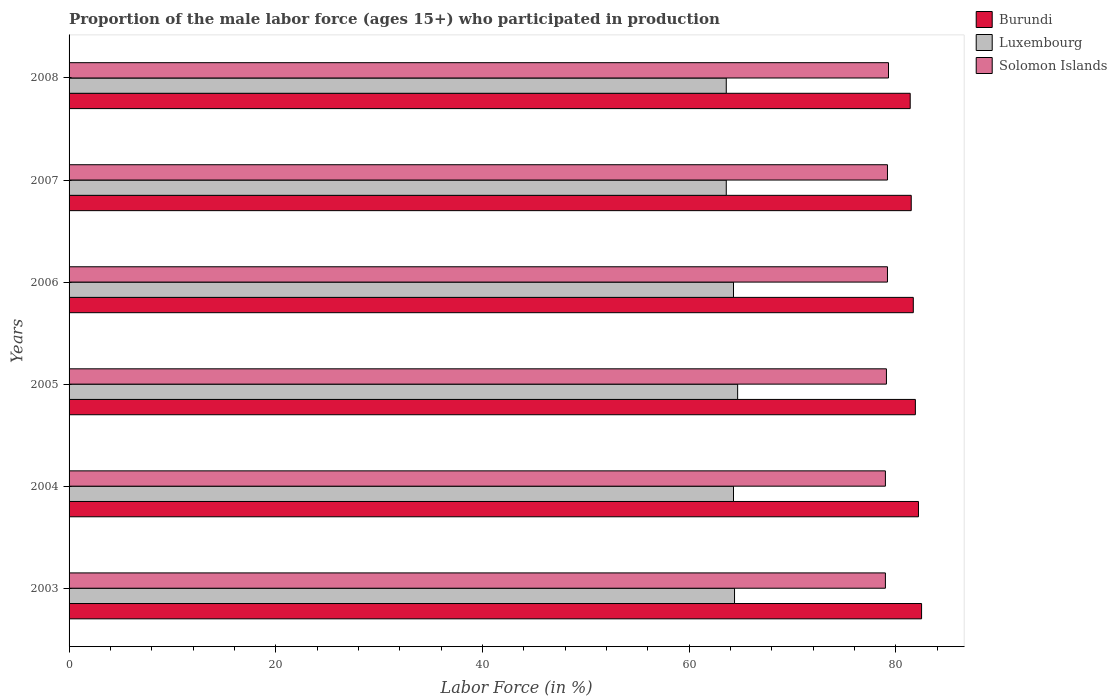Are the number of bars per tick equal to the number of legend labels?
Make the answer very short. Yes. Are the number of bars on each tick of the Y-axis equal?
Offer a very short reply. Yes. How many bars are there on the 3rd tick from the top?
Keep it short and to the point. 3. What is the label of the 4th group of bars from the top?
Your answer should be very brief. 2005. What is the proportion of the male labor force who participated in production in Solomon Islands in 2008?
Your answer should be compact. 79.3. Across all years, what is the maximum proportion of the male labor force who participated in production in Burundi?
Offer a very short reply. 82.5. Across all years, what is the minimum proportion of the male labor force who participated in production in Burundi?
Your answer should be very brief. 81.4. In which year was the proportion of the male labor force who participated in production in Burundi minimum?
Provide a short and direct response. 2008. What is the total proportion of the male labor force who participated in production in Solomon Islands in the graph?
Keep it short and to the point. 474.8. What is the difference between the proportion of the male labor force who participated in production in Solomon Islands in 2004 and that in 2007?
Give a very brief answer. -0.2. What is the difference between the proportion of the male labor force who participated in production in Luxembourg in 2006 and the proportion of the male labor force who participated in production in Burundi in 2005?
Make the answer very short. -17.6. What is the average proportion of the male labor force who participated in production in Burundi per year?
Offer a terse response. 81.87. In the year 2003, what is the difference between the proportion of the male labor force who participated in production in Luxembourg and proportion of the male labor force who participated in production in Solomon Islands?
Provide a succinct answer. -14.6. In how many years, is the proportion of the male labor force who participated in production in Luxembourg greater than 4 %?
Make the answer very short. 6. What is the ratio of the proportion of the male labor force who participated in production in Burundi in 2005 to that in 2006?
Provide a short and direct response. 1. Is the proportion of the male labor force who participated in production in Solomon Islands in 2004 less than that in 2006?
Give a very brief answer. Yes. Is the difference between the proportion of the male labor force who participated in production in Luxembourg in 2005 and 2008 greater than the difference between the proportion of the male labor force who participated in production in Solomon Islands in 2005 and 2008?
Keep it short and to the point. Yes. What is the difference between the highest and the second highest proportion of the male labor force who participated in production in Solomon Islands?
Your response must be concise. 0.1. What is the difference between the highest and the lowest proportion of the male labor force who participated in production in Luxembourg?
Your answer should be very brief. 1.1. Is the sum of the proportion of the male labor force who participated in production in Luxembourg in 2004 and 2006 greater than the maximum proportion of the male labor force who participated in production in Solomon Islands across all years?
Offer a very short reply. Yes. What does the 2nd bar from the top in 2004 represents?
Make the answer very short. Luxembourg. What does the 3rd bar from the bottom in 2004 represents?
Provide a succinct answer. Solomon Islands. Are all the bars in the graph horizontal?
Provide a succinct answer. Yes. Are the values on the major ticks of X-axis written in scientific E-notation?
Keep it short and to the point. No. Where does the legend appear in the graph?
Provide a succinct answer. Top right. How many legend labels are there?
Your answer should be compact. 3. What is the title of the graph?
Ensure brevity in your answer.  Proportion of the male labor force (ages 15+) who participated in production. What is the Labor Force (in %) in Burundi in 2003?
Provide a short and direct response. 82.5. What is the Labor Force (in %) in Luxembourg in 2003?
Ensure brevity in your answer.  64.4. What is the Labor Force (in %) in Solomon Islands in 2003?
Offer a very short reply. 79. What is the Labor Force (in %) of Burundi in 2004?
Offer a very short reply. 82.2. What is the Labor Force (in %) in Luxembourg in 2004?
Ensure brevity in your answer.  64.3. What is the Labor Force (in %) in Solomon Islands in 2004?
Provide a succinct answer. 79. What is the Labor Force (in %) in Burundi in 2005?
Your answer should be very brief. 81.9. What is the Labor Force (in %) of Luxembourg in 2005?
Give a very brief answer. 64.7. What is the Labor Force (in %) in Solomon Islands in 2005?
Your answer should be compact. 79.1. What is the Labor Force (in %) of Burundi in 2006?
Provide a short and direct response. 81.7. What is the Labor Force (in %) of Luxembourg in 2006?
Give a very brief answer. 64.3. What is the Labor Force (in %) in Solomon Islands in 2006?
Give a very brief answer. 79.2. What is the Labor Force (in %) of Burundi in 2007?
Ensure brevity in your answer.  81.5. What is the Labor Force (in %) of Luxembourg in 2007?
Provide a succinct answer. 63.6. What is the Labor Force (in %) of Solomon Islands in 2007?
Offer a terse response. 79.2. What is the Labor Force (in %) of Burundi in 2008?
Offer a very short reply. 81.4. What is the Labor Force (in %) in Luxembourg in 2008?
Offer a terse response. 63.6. What is the Labor Force (in %) of Solomon Islands in 2008?
Ensure brevity in your answer.  79.3. Across all years, what is the maximum Labor Force (in %) in Burundi?
Give a very brief answer. 82.5. Across all years, what is the maximum Labor Force (in %) of Luxembourg?
Provide a succinct answer. 64.7. Across all years, what is the maximum Labor Force (in %) of Solomon Islands?
Offer a very short reply. 79.3. Across all years, what is the minimum Labor Force (in %) of Burundi?
Your answer should be very brief. 81.4. Across all years, what is the minimum Labor Force (in %) of Luxembourg?
Ensure brevity in your answer.  63.6. Across all years, what is the minimum Labor Force (in %) in Solomon Islands?
Keep it short and to the point. 79. What is the total Labor Force (in %) in Burundi in the graph?
Offer a terse response. 491.2. What is the total Labor Force (in %) in Luxembourg in the graph?
Give a very brief answer. 384.9. What is the total Labor Force (in %) of Solomon Islands in the graph?
Provide a succinct answer. 474.8. What is the difference between the Labor Force (in %) in Burundi in 2003 and that in 2004?
Ensure brevity in your answer.  0.3. What is the difference between the Labor Force (in %) in Luxembourg in 2003 and that in 2004?
Offer a terse response. 0.1. What is the difference between the Labor Force (in %) of Burundi in 2003 and that in 2005?
Offer a very short reply. 0.6. What is the difference between the Labor Force (in %) in Luxembourg in 2003 and that in 2005?
Your answer should be very brief. -0.3. What is the difference between the Labor Force (in %) in Burundi in 2003 and that in 2006?
Your answer should be compact. 0.8. What is the difference between the Labor Force (in %) in Solomon Islands in 2003 and that in 2006?
Your answer should be compact. -0.2. What is the difference between the Labor Force (in %) in Solomon Islands in 2003 and that in 2008?
Give a very brief answer. -0.3. What is the difference between the Labor Force (in %) of Burundi in 2004 and that in 2005?
Offer a terse response. 0.3. What is the difference between the Labor Force (in %) in Solomon Islands in 2004 and that in 2005?
Keep it short and to the point. -0.1. What is the difference between the Labor Force (in %) in Luxembourg in 2004 and that in 2006?
Your response must be concise. 0. What is the difference between the Labor Force (in %) in Solomon Islands in 2004 and that in 2006?
Keep it short and to the point. -0.2. What is the difference between the Labor Force (in %) of Solomon Islands in 2004 and that in 2007?
Provide a short and direct response. -0.2. What is the difference between the Labor Force (in %) in Luxembourg in 2004 and that in 2008?
Your answer should be compact. 0.7. What is the difference between the Labor Force (in %) in Burundi in 2005 and that in 2006?
Your answer should be compact. 0.2. What is the difference between the Labor Force (in %) in Burundi in 2005 and that in 2007?
Give a very brief answer. 0.4. What is the difference between the Labor Force (in %) of Luxembourg in 2005 and that in 2007?
Your answer should be compact. 1.1. What is the difference between the Labor Force (in %) in Solomon Islands in 2005 and that in 2007?
Offer a very short reply. -0.1. What is the difference between the Labor Force (in %) of Burundi in 2005 and that in 2008?
Provide a succinct answer. 0.5. What is the difference between the Labor Force (in %) in Luxembourg in 2005 and that in 2008?
Provide a short and direct response. 1.1. What is the difference between the Labor Force (in %) of Solomon Islands in 2005 and that in 2008?
Offer a terse response. -0.2. What is the difference between the Labor Force (in %) of Solomon Islands in 2006 and that in 2007?
Give a very brief answer. 0. What is the difference between the Labor Force (in %) of Burundi in 2006 and that in 2008?
Provide a succinct answer. 0.3. What is the difference between the Labor Force (in %) of Solomon Islands in 2006 and that in 2008?
Provide a short and direct response. -0.1. What is the difference between the Labor Force (in %) in Luxembourg in 2007 and that in 2008?
Make the answer very short. 0. What is the difference between the Labor Force (in %) of Solomon Islands in 2007 and that in 2008?
Offer a terse response. -0.1. What is the difference between the Labor Force (in %) of Burundi in 2003 and the Labor Force (in %) of Solomon Islands in 2004?
Ensure brevity in your answer.  3.5. What is the difference between the Labor Force (in %) in Luxembourg in 2003 and the Labor Force (in %) in Solomon Islands in 2004?
Ensure brevity in your answer.  -14.6. What is the difference between the Labor Force (in %) of Burundi in 2003 and the Labor Force (in %) of Luxembourg in 2005?
Offer a very short reply. 17.8. What is the difference between the Labor Force (in %) of Luxembourg in 2003 and the Labor Force (in %) of Solomon Islands in 2005?
Your response must be concise. -14.7. What is the difference between the Labor Force (in %) of Burundi in 2003 and the Labor Force (in %) of Solomon Islands in 2006?
Give a very brief answer. 3.3. What is the difference between the Labor Force (in %) of Luxembourg in 2003 and the Labor Force (in %) of Solomon Islands in 2006?
Ensure brevity in your answer.  -14.8. What is the difference between the Labor Force (in %) in Luxembourg in 2003 and the Labor Force (in %) in Solomon Islands in 2007?
Provide a short and direct response. -14.8. What is the difference between the Labor Force (in %) in Burundi in 2003 and the Labor Force (in %) in Luxembourg in 2008?
Keep it short and to the point. 18.9. What is the difference between the Labor Force (in %) of Luxembourg in 2003 and the Labor Force (in %) of Solomon Islands in 2008?
Provide a succinct answer. -14.9. What is the difference between the Labor Force (in %) in Luxembourg in 2004 and the Labor Force (in %) in Solomon Islands in 2005?
Your response must be concise. -14.8. What is the difference between the Labor Force (in %) of Burundi in 2004 and the Labor Force (in %) of Luxembourg in 2006?
Make the answer very short. 17.9. What is the difference between the Labor Force (in %) of Luxembourg in 2004 and the Labor Force (in %) of Solomon Islands in 2006?
Your answer should be very brief. -14.9. What is the difference between the Labor Force (in %) of Burundi in 2004 and the Labor Force (in %) of Solomon Islands in 2007?
Ensure brevity in your answer.  3. What is the difference between the Labor Force (in %) in Luxembourg in 2004 and the Labor Force (in %) in Solomon Islands in 2007?
Ensure brevity in your answer.  -14.9. What is the difference between the Labor Force (in %) of Burundi in 2004 and the Labor Force (in %) of Luxembourg in 2008?
Your answer should be very brief. 18.6. What is the difference between the Labor Force (in %) in Burundi in 2005 and the Labor Force (in %) in Luxembourg in 2006?
Offer a very short reply. 17.6. What is the difference between the Labor Force (in %) in Burundi in 2005 and the Labor Force (in %) in Solomon Islands in 2006?
Your answer should be compact. 2.7. What is the difference between the Labor Force (in %) in Luxembourg in 2005 and the Labor Force (in %) in Solomon Islands in 2006?
Offer a very short reply. -14.5. What is the difference between the Labor Force (in %) in Burundi in 2005 and the Labor Force (in %) in Solomon Islands in 2007?
Keep it short and to the point. 2.7. What is the difference between the Labor Force (in %) in Burundi in 2005 and the Labor Force (in %) in Luxembourg in 2008?
Make the answer very short. 18.3. What is the difference between the Labor Force (in %) of Luxembourg in 2005 and the Labor Force (in %) of Solomon Islands in 2008?
Give a very brief answer. -14.6. What is the difference between the Labor Force (in %) of Burundi in 2006 and the Labor Force (in %) of Luxembourg in 2007?
Provide a short and direct response. 18.1. What is the difference between the Labor Force (in %) of Luxembourg in 2006 and the Labor Force (in %) of Solomon Islands in 2007?
Your response must be concise. -14.9. What is the difference between the Labor Force (in %) in Luxembourg in 2007 and the Labor Force (in %) in Solomon Islands in 2008?
Your answer should be very brief. -15.7. What is the average Labor Force (in %) in Burundi per year?
Give a very brief answer. 81.87. What is the average Labor Force (in %) in Luxembourg per year?
Your answer should be compact. 64.15. What is the average Labor Force (in %) of Solomon Islands per year?
Offer a very short reply. 79.13. In the year 2003, what is the difference between the Labor Force (in %) of Burundi and Labor Force (in %) of Solomon Islands?
Your response must be concise. 3.5. In the year 2003, what is the difference between the Labor Force (in %) in Luxembourg and Labor Force (in %) in Solomon Islands?
Your answer should be compact. -14.6. In the year 2004, what is the difference between the Labor Force (in %) in Burundi and Labor Force (in %) in Luxembourg?
Offer a terse response. 17.9. In the year 2004, what is the difference between the Labor Force (in %) of Burundi and Labor Force (in %) of Solomon Islands?
Keep it short and to the point. 3.2. In the year 2004, what is the difference between the Labor Force (in %) in Luxembourg and Labor Force (in %) in Solomon Islands?
Provide a short and direct response. -14.7. In the year 2005, what is the difference between the Labor Force (in %) of Burundi and Labor Force (in %) of Solomon Islands?
Your answer should be very brief. 2.8. In the year 2005, what is the difference between the Labor Force (in %) of Luxembourg and Labor Force (in %) of Solomon Islands?
Make the answer very short. -14.4. In the year 2006, what is the difference between the Labor Force (in %) of Burundi and Labor Force (in %) of Luxembourg?
Offer a very short reply. 17.4. In the year 2006, what is the difference between the Labor Force (in %) of Burundi and Labor Force (in %) of Solomon Islands?
Offer a very short reply. 2.5. In the year 2006, what is the difference between the Labor Force (in %) in Luxembourg and Labor Force (in %) in Solomon Islands?
Keep it short and to the point. -14.9. In the year 2007, what is the difference between the Labor Force (in %) of Burundi and Labor Force (in %) of Luxembourg?
Make the answer very short. 17.9. In the year 2007, what is the difference between the Labor Force (in %) in Burundi and Labor Force (in %) in Solomon Islands?
Provide a succinct answer. 2.3. In the year 2007, what is the difference between the Labor Force (in %) of Luxembourg and Labor Force (in %) of Solomon Islands?
Make the answer very short. -15.6. In the year 2008, what is the difference between the Labor Force (in %) in Burundi and Labor Force (in %) in Luxembourg?
Your answer should be compact. 17.8. In the year 2008, what is the difference between the Labor Force (in %) in Luxembourg and Labor Force (in %) in Solomon Islands?
Your answer should be very brief. -15.7. What is the ratio of the Labor Force (in %) of Burundi in 2003 to that in 2004?
Provide a short and direct response. 1. What is the ratio of the Labor Force (in %) of Luxembourg in 2003 to that in 2004?
Offer a very short reply. 1. What is the ratio of the Labor Force (in %) in Burundi in 2003 to that in 2005?
Your response must be concise. 1.01. What is the ratio of the Labor Force (in %) of Luxembourg in 2003 to that in 2005?
Offer a very short reply. 1. What is the ratio of the Labor Force (in %) of Burundi in 2003 to that in 2006?
Ensure brevity in your answer.  1.01. What is the ratio of the Labor Force (in %) in Solomon Islands in 2003 to that in 2006?
Your response must be concise. 1. What is the ratio of the Labor Force (in %) in Burundi in 2003 to that in 2007?
Give a very brief answer. 1.01. What is the ratio of the Labor Force (in %) of Luxembourg in 2003 to that in 2007?
Keep it short and to the point. 1.01. What is the ratio of the Labor Force (in %) of Solomon Islands in 2003 to that in 2007?
Offer a terse response. 1. What is the ratio of the Labor Force (in %) of Burundi in 2003 to that in 2008?
Provide a short and direct response. 1.01. What is the ratio of the Labor Force (in %) in Luxembourg in 2003 to that in 2008?
Offer a terse response. 1.01. What is the ratio of the Labor Force (in %) in Solomon Islands in 2003 to that in 2008?
Give a very brief answer. 1. What is the ratio of the Labor Force (in %) of Burundi in 2004 to that in 2005?
Provide a succinct answer. 1. What is the ratio of the Labor Force (in %) in Luxembourg in 2004 to that in 2006?
Ensure brevity in your answer.  1. What is the ratio of the Labor Force (in %) of Solomon Islands in 2004 to that in 2006?
Provide a short and direct response. 1. What is the ratio of the Labor Force (in %) of Burundi in 2004 to that in 2007?
Keep it short and to the point. 1.01. What is the ratio of the Labor Force (in %) of Luxembourg in 2004 to that in 2007?
Ensure brevity in your answer.  1.01. What is the ratio of the Labor Force (in %) in Solomon Islands in 2004 to that in 2007?
Provide a succinct answer. 1. What is the ratio of the Labor Force (in %) of Burundi in 2004 to that in 2008?
Your answer should be compact. 1.01. What is the ratio of the Labor Force (in %) of Solomon Islands in 2004 to that in 2008?
Keep it short and to the point. 1. What is the ratio of the Labor Force (in %) of Burundi in 2005 to that in 2006?
Give a very brief answer. 1. What is the ratio of the Labor Force (in %) of Luxembourg in 2005 to that in 2007?
Give a very brief answer. 1.02. What is the ratio of the Labor Force (in %) of Burundi in 2005 to that in 2008?
Ensure brevity in your answer.  1.01. What is the ratio of the Labor Force (in %) in Luxembourg in 2005 to that in 2008?
Ensure brevity in your answer.  1.02. What is the ratio of the Labor Force (in %) in Solomon Islands in 2005 to that in 2008?
Your answer should be compact. 1. What is the ratio of the Labor Force (in %) of Burundi in 2006 to that in 2007?
Offer a terse response. 1. What is the ratio of the Labor Force (in %) of Burundi in 2006 to that in 2008?
Offer a terse response. 1. What is the ratio of the Labor Force (in %) of Burundi in 2007 to that in 2008?
Provide a short and direct response. 1. What is the ratio of the Labor Force (in %) of Luxembourg in 2007 to that in 2008?
Offer a terse response. 1. What is the ratio of the Labor Force (in %) of Solomon Islands in 2007 to that in 2008?
Your response must be concise. 1. What is the difference between the highest and the second highest Labor Force (in %) of Burundi?
Give a very brief answer. 0.3. What is the difference between the highest and the second highest Labor Force (in %) of Luxembourg?
Give a very brief answer. 0.3. What is the difference between the highest and the second highest Labor Force (in %) in Solomon Islands?
Keep it short and to the point. 0.1. What is the difference between the highest and the lowest Labor Force (in %) of Burundi?
Ensure brevity in your answer.  1.1. What is the difference between the highest and the lowest Labor Force (in %) in Luxembourg?
Provide a short and direct response. 1.1. 